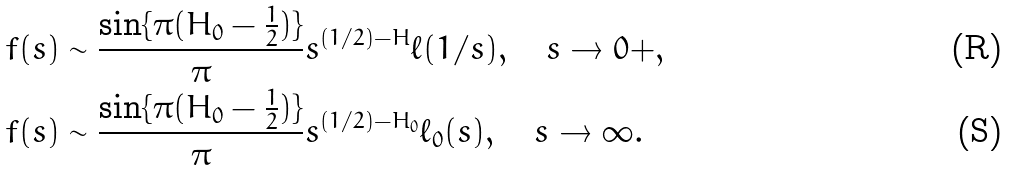<formula> <loc_0><loc_0><loc_500><loc_500>& f ( s ) \sim \frac { \sin \{ \pi ( H _ { 0 } - \frac { 1 } { 2 } ) \} } { \pi } s ^ { ( 1 / 2 ) - H } \ell ( 1 / s ) , \quad s \to 0 + , \\ & f ( s ) \sim \frac { \sin \{ \pi ( H _ { 0 } - \frac { 1 } { 2 } ) \} } { \pi } s ^ { ( 1 / 2 ) - H _ { 0 } } \ell _ { 0 } ( s ) , \quad s \to \infty .</formula> 